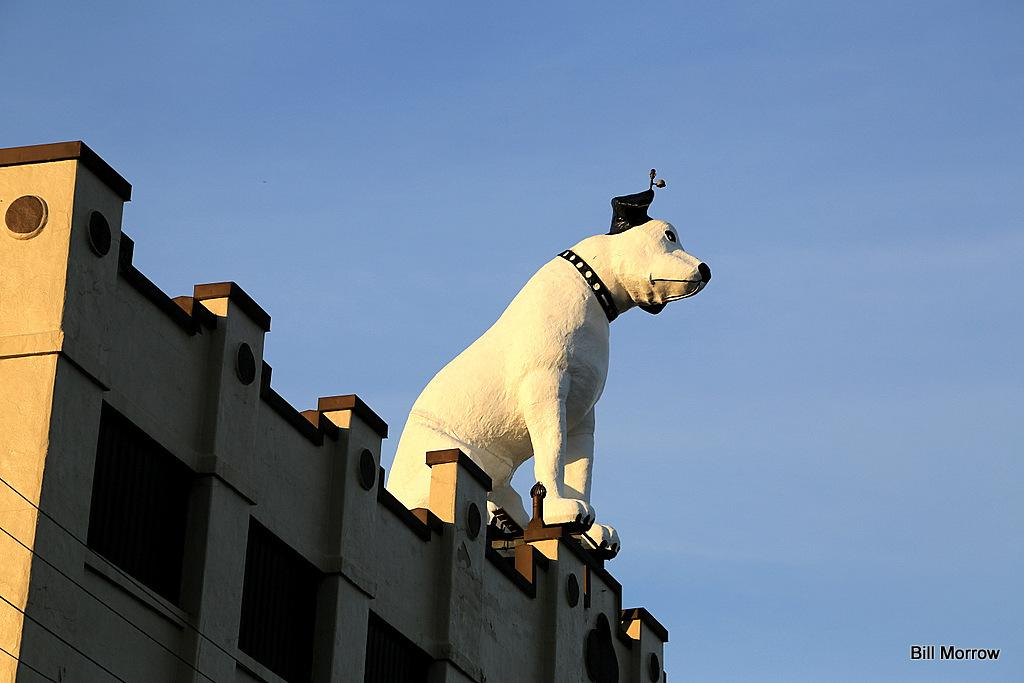What type of sculpture is present in the image? There is a sculpture of a dog in the image. What other structures or objects can be seen in the image? There is a building visible in the image. Is there any text or marking in the image? Yes, there is a watermark in the bottom right corner of the image. What can be seen in the background of the image? The sky is visible in the image. What type of cooking apparatus is present in the image? There is no cooking apparatus present in the image. What type of sink can be seen in the image? There is no sink present in the image. 